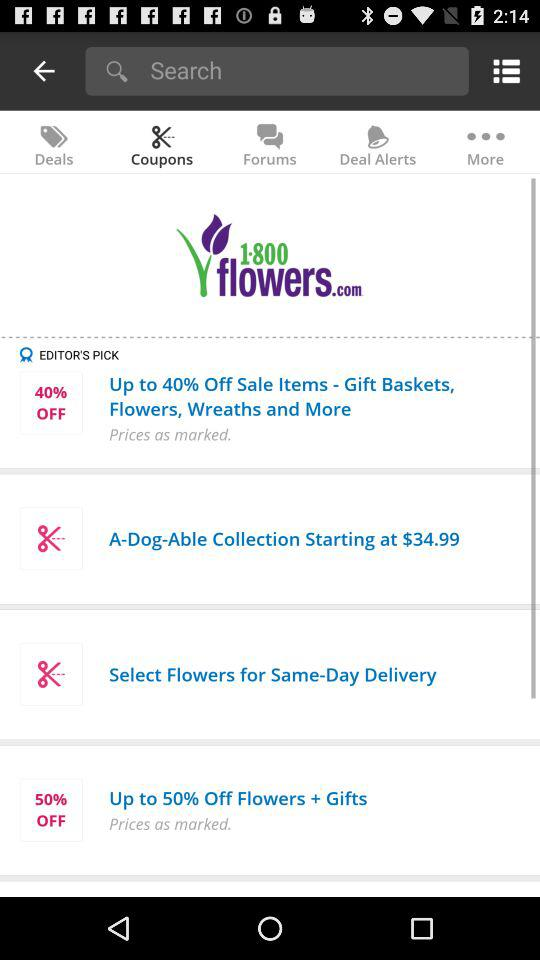Which items are available at up to 40% off? The items that are available at up to 40% off are gift baskets, flowers, wreaths and more. 